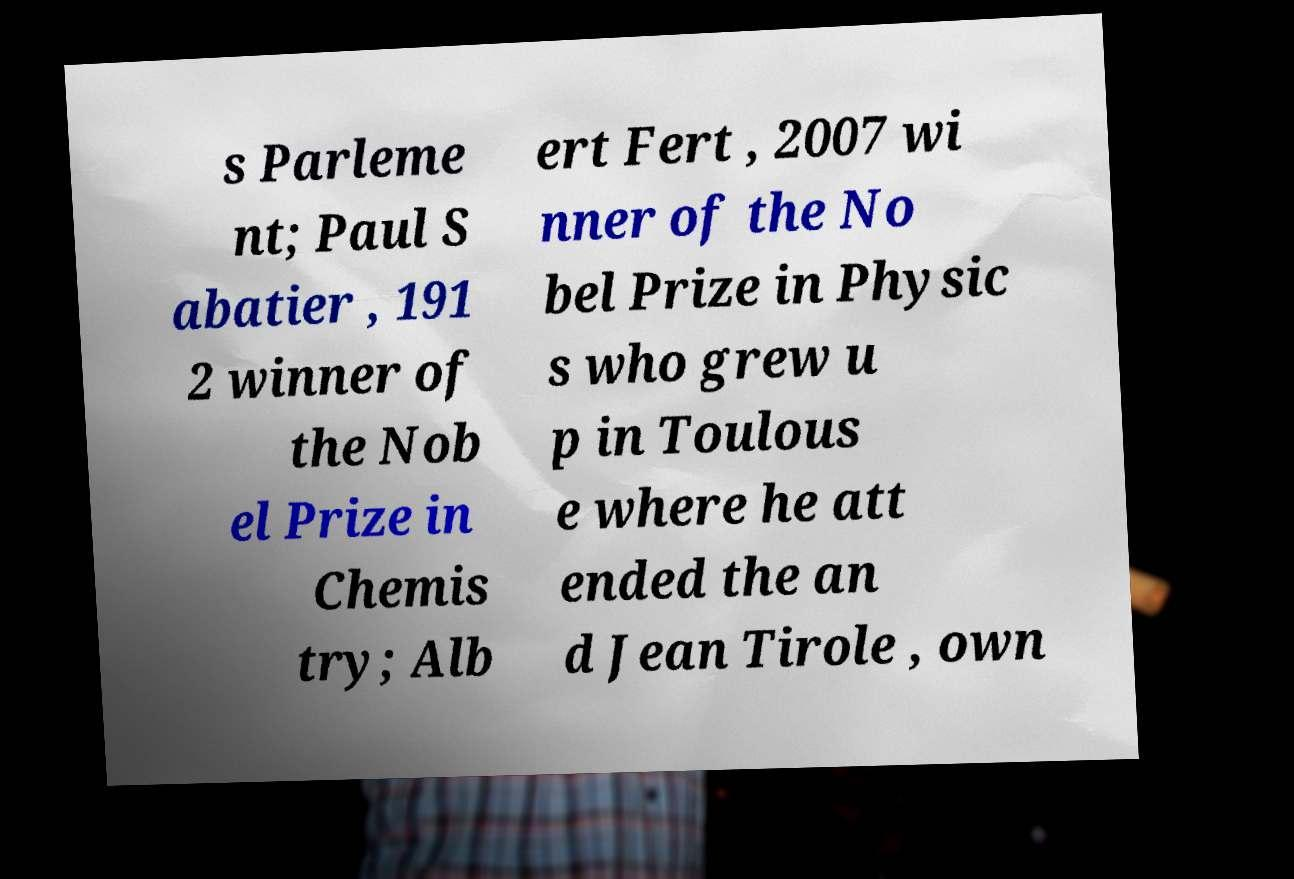Can you accurately transcribe the text from the provided image for me? s Parleme nt; Paul S abatier , 191 2 winner of the Nob el Prize in Chemis try; Alb ert Fert , 2007 wi nner of the No bel Prize in Physic s who grew u p in Toulous e where he att ended the an d Jean Tirole , own 